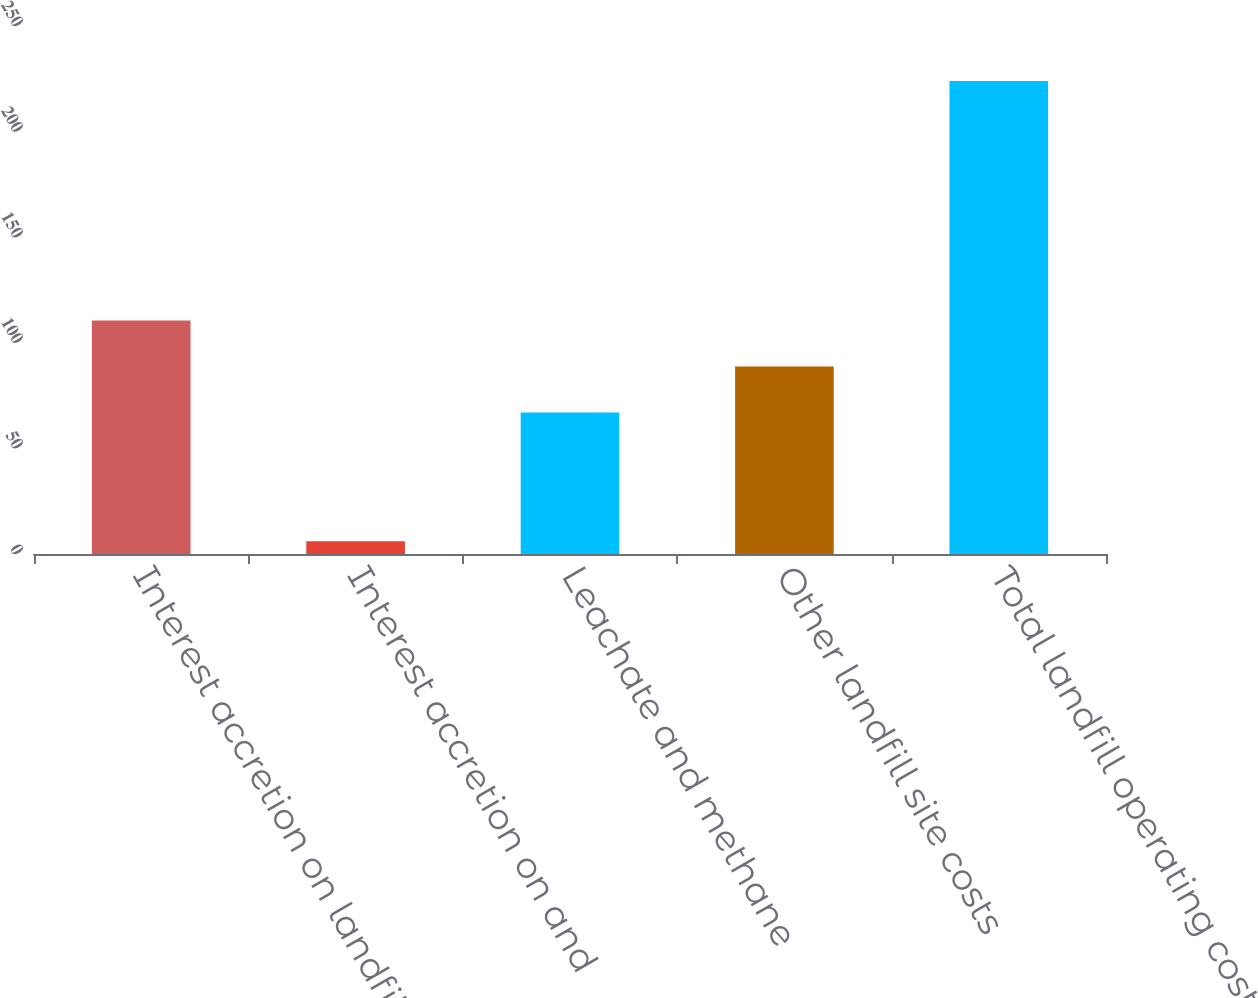Convert chart. <chart><loc_0><loc_0><loc_500><loc_500><bar_chart><fcel>Interest accretion on landfill<fcel>Interest accretion on and<fcel>Leachate and methane<fcel>Other landfill site costs<fcel>Total landfill operating costs<nl><fcel>110.6<fcel>6<fcel>67<fcel>88.8<fcel>224<nl></chart> 